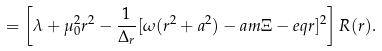<formula> <loc_0><loc_0><loc_500><loc_500>= \left [ { \lambda + \mu _ { 0 } ^ { 2 } r ^ { 2 } - \frac { 1 } { \Delta _ { r } } [ \omega ( r ^ { 2 } + a ^ { 2 } ) - a m \Xi - e q r ] ^ { 2 } } \right ] R ( r ) .</formula> 